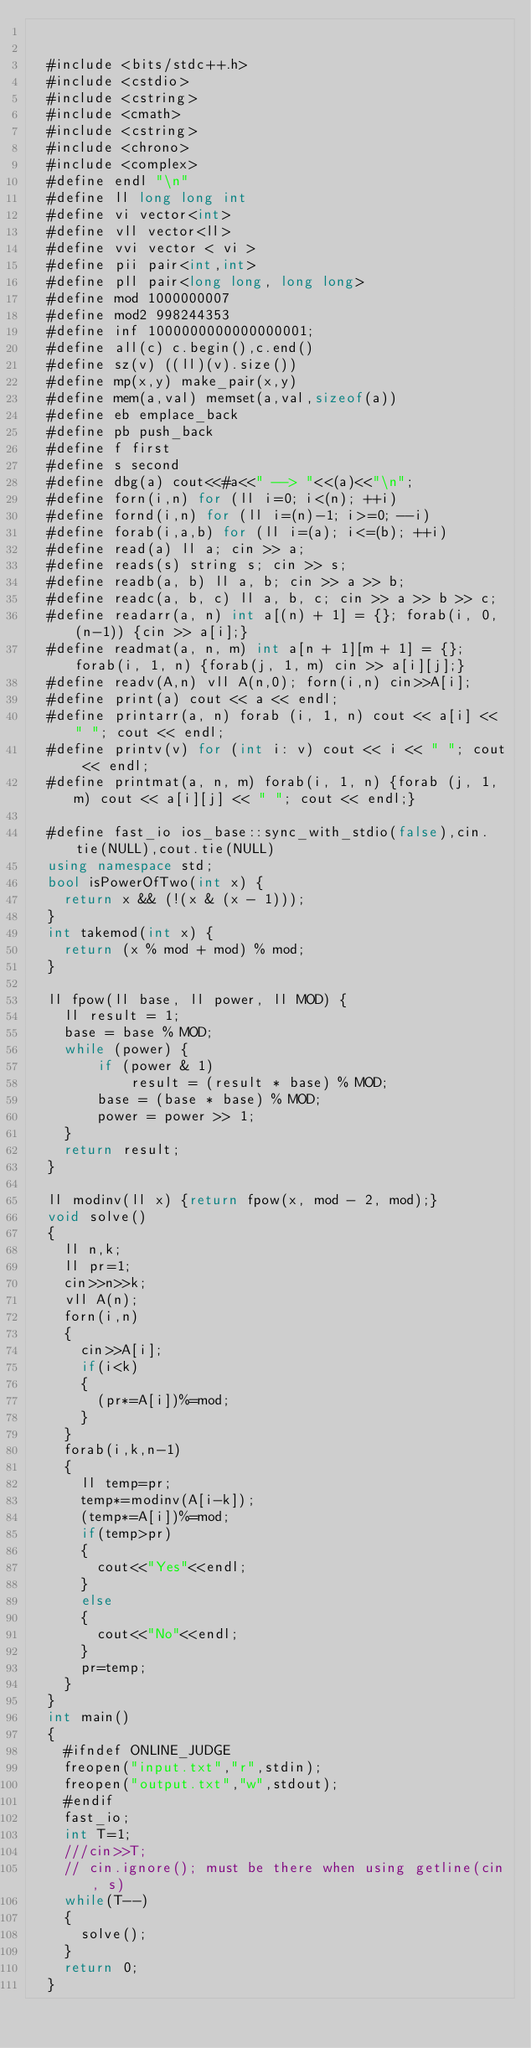Convert code to text. <code><loc_0><loc_0><loc_500><loc_500><_C++_>
	
	#include <bits/stdc++.h>
	#include <cstdio>
	#include <cstring>
	#include <cmath>
	#include <cstring>
	#include <chrono>
	#include <complex>
	#define endl "\n"	
	#define ll long long int
	#define vi vector<int>
	#define vll vector<ll>
	#define vvi vector < vi >
	#define pii pair<int,int>
	#define pll pair<long long, long long>
	#define mod 1000000007
	#define mod2 998244353
	#define inf 1000000000000000001;
	#define all(c) c.begin(),c.end()
	#define sz(v) ((ll)(v).size())
	#define mp(x,y) make_pair(x,y)
	#define mem(a,val) memset(a,val,sizeof(a))
	#define eb emplace_back
	#define pb push_back
	#define f first
	#define s second
	#define dbg(a) cout<<#a<<" --> "<<(a)<<"\n";
	#define forn(i,n) for (ll i=0; i<(n); ++i)
	#define fornd(i,n) for (ll i=(n)-1; i>=0; --i)	
	#define forab(i,a,b) for (ll i=(a); i<=(b); ++i)
	#define read(a) ll a; cin >> a;
	#define reads(s) string s; cin >> s;
	#define readb(a, b) ll a, b; cin >> a >> b;
	#define readc(a, b, c) ll a, b, c; cin >> a >> b >> c;
	#define readarr(a, n) int a[(n) + 1] = {}; forab(i, 0, (n-1)) {cin >> a[i];}
	#define readmat(a, n, m) int a[n + 1][m + 1] = {}; forab(i, 1, n) {forab(j, 1, m) cin >> a[i][j];}
	#define readv(A,n) vll A(n,0); forn(i,n) cin>>A[i]; 
	#define print(a) cout << a << endl;
	#define printarr(a, n) forab (i, 1, n) cout << a[i] << " "; cout << endl;
	#define printv(v) for (int i: v) cout << i << " "; cout << endl;
	#define printmat(a, n, m) forab(i, 1, n) {forab (j, 1, m) cout << a[i][j] << " "; cout << endl;}
	 
	#define fast_io ios_base::sync_with_stdio(false),cin.tie(NULL),cout.tie(NULL)
	using namespace std;
	bool isPowerOfTwo(int x) {
    return x && (!(x & (x - 1)));
	}
	int takemod(int x) {
    return (x % mod + mod) % mod;
	}
 
	ll fpow(ll base, ll power, ll MOD) {
    ll result = 1;
    base = base % MOD;
    while (power) {
        if (power & 1)
            result = (result * base) % MOD;
        base = (base * base) % MOD;
        power = power >> 1;
    }
    return result;
	}
 
	ll modinv(ll x) {return fpow(x, mod - 2, mod);}
	void solve()
	{
		ll n,k;
		ll pr=1;
		cin>>n>>k;
		vll A(n);
		forn(i,n)
		{
			cin>>A[i];
			if(i<k)
			{
				(pr*=A[i])%=mod;
			}
		}		
		forab(i,k,n-1)
		{
			ll temp=pr;
			temp*=modinv(A[i-k]);
			(temp*=A[i])%=mod;
			if(temp>pr)
			{
				cout<<"Yes"<<endl;
			}
			else
			{
				cout<<"No"<<endl;
			}
			pr=temp;
		}
	}
	int main()
	{	
		#ifndef ONLINE_JUDGE
		freopen("input.txt","r",stdin);
		freopen("output.txt","w",stdout);
		#endif
		fast_io;
		int T=1;
		///cin>>T;
		// cin.ignore(); must be there when using getline(cin, s)
		while(T--)
		{
			solve();
		}
		return 0;
	}

	
	</code> 